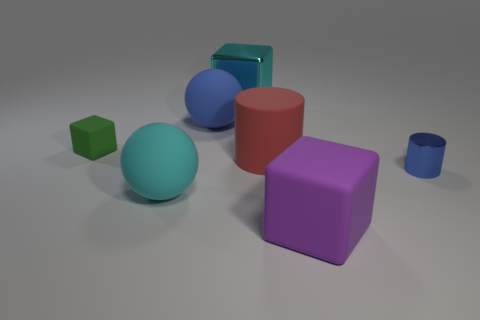Subtract all big blocks. How many blocks are left? 1 Add 3 big purple blocks. How many objects exist? 10 Subtract all gray cubes. Subtract all red cylinders. How many cubes are left? 3 Subtract all yellow cubes. How many green balls are left? 0 Subtract all small objects. Subtract all big things. How many objects are left? 0 Add 7 large spheres. How many large spheres are left? 9 Add 2 small blue cylinders. How many small blue cylinders exist? 3 Subtract all cyan balls. How many balls are left? 1 Subtract 0 gray cylinders. How many objects are left? 7 Subtract all blocks. How many objects are left? 4 